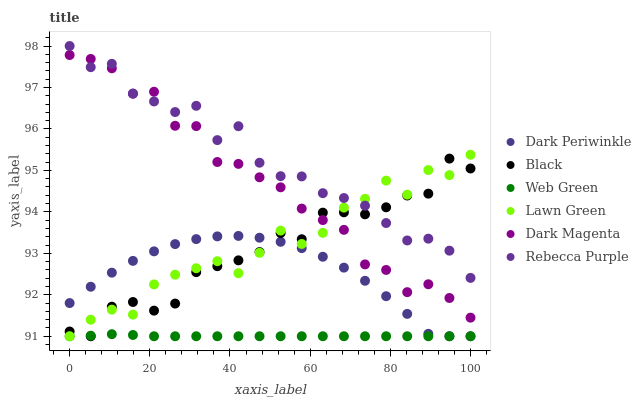Does Web Green have the minimum area under the curve?
Answer yes or no. Yes. Does Rebecca Purple have the maximum area under the curve?
Answer yes or no. Yes. Does Dark Magenta have the minimum area under the curve?
Answer yes or no. No. Does Dark Magenta have the maximum area under the curve?
Answer yes or no. No. Is Web Green the smoothest?
Answer yes or no. Yes. Is Rebecca Purple the roughest?
Answer yes or no. Yes. Is Dark Magenta the smoothest?
Answer yes or no. No. Is Dark Magenta the roughest?
Answer yes or no. No. Does Lawn Green have the lowest value?
Answer yes or no. Yes. Does Dark Magenta have the lowest value?
Answer yes or no. No. Does Rebecca Purple have the highest value?
Answer yes or no. Yes. Does Dark Magenta have the highest value?
Answer yes or no. No. Is Dark Periwinkle less than Rebecca Purple?
Answer yes or no. Yes. Is Dark Magenta greater than Dark Periwinkle?
Answer yes or no. Yes. Does Rebecca Purple intersect Black?
Answer yes or no. Yes. Is Rebecca Purple less than Black?
Answer yes or no. No. Is Rebecca Purple greater than Black?
Answer yes or no. No. Does Dark Periwinkle intersect Rebecca Purple?
Answer yes or no. No. 